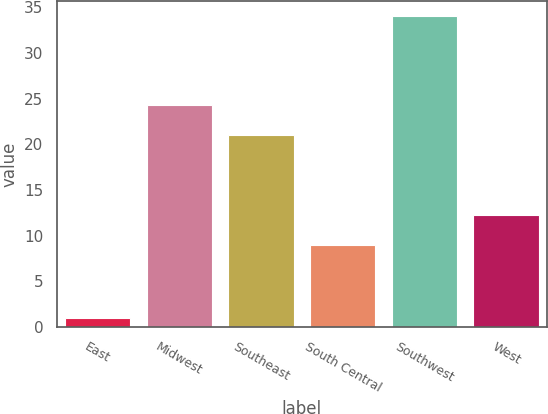Convert chart. <chart><loc_0><loc_0><loc_500><loc_500><bar_chart><fcel>East<fcel>Midwest<fcel>Southeast<fcel>South Central<fcel>Southwest<fcel>West<nl><fcel>1<fcel>24.3<fcel>21<fcel>9<fcel>34<fcel>12.3<nl></chart> 